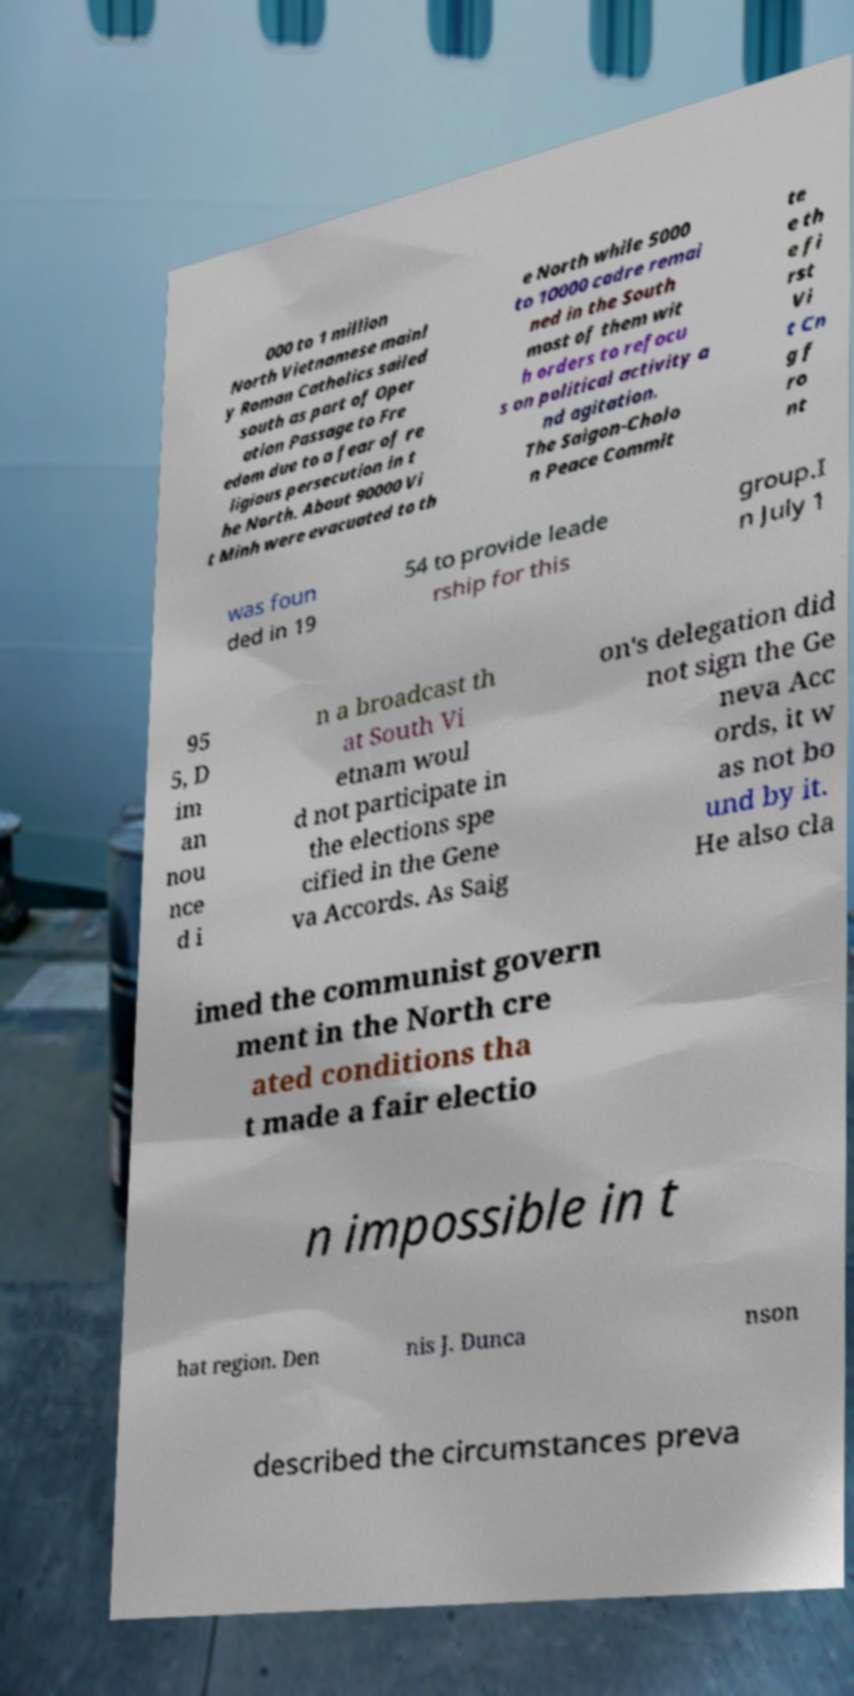Please read and relay the text visible in this image. What does it say? 000 to 1 million North Vietnamese mainl y Roman Catholics sailed south as part of Oper ation Passage to Fre edom due to a fear of re ligious persecution in t he North. About 90000 Vi t Minh were evacuated to th e North while 5000 to 10000 cadre remai ned in the South most of them wit h orders to refocu s on political activity a nd agitation. The Saigon-Cholo n Peace Commit te e th e fi rst Vi t Cn g f ro nt was foun ded in 19 54 to provide leade rship for this group.I n July 1 95 5, D im an nou nce d i n a broadcast th at South Vi etnam woul d not participate in the elections spe cified in the Gene va Accords. As Saig on's delegation did not sign the Ge neva Acc ords, it w as not bo und by it. He also cla imed the communist govern ment in the North cre ated conditions tha t made a fair electio n impossible in t hat region. Den nis J. Dunca nson described the circumstances preva 